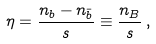Convert formula to latex. <formula><loc_0><loc_0><loc_500><loc_500>\eta = \frac { n _ { b } - n _ { \bar { b } } } { s } \equiv \frac { n _ { B } } { s } \, ,</formula> 